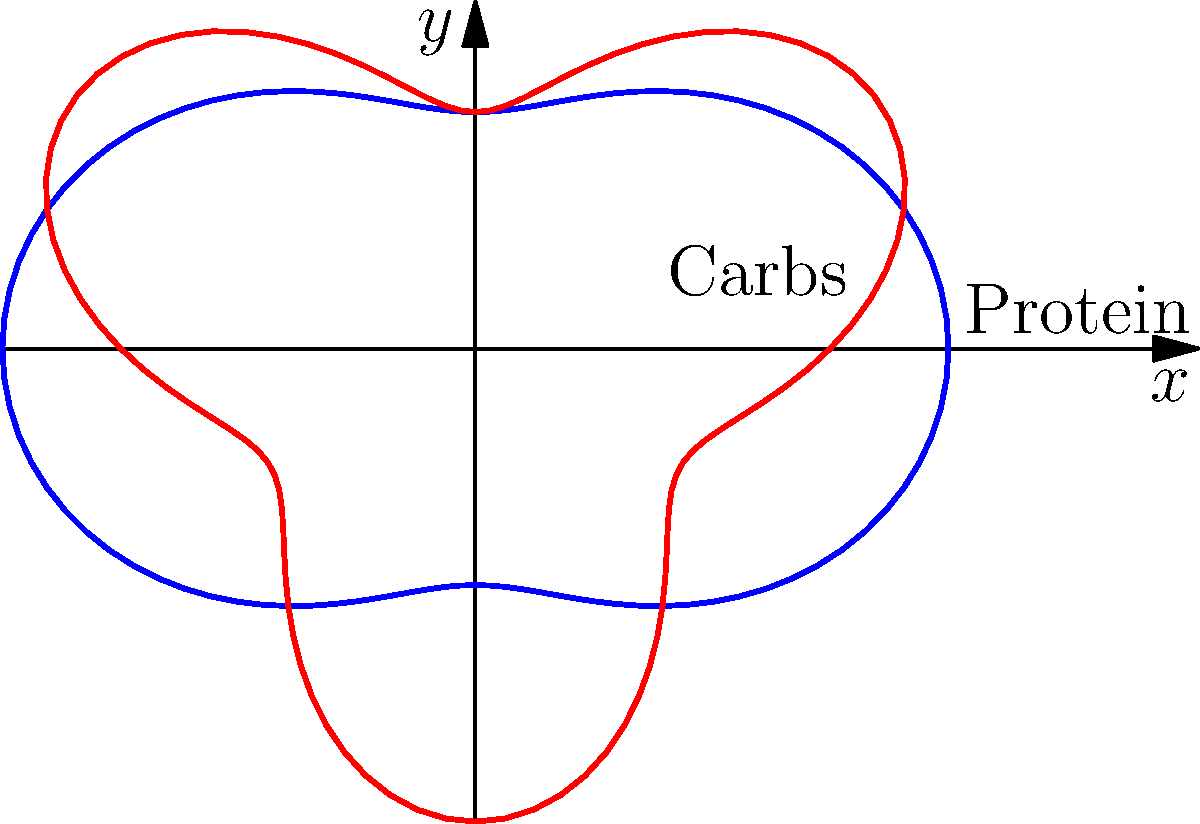The polar curves $r=3+\cos(2\theta)$ and $r=3+\sin(3\theta)$ represent the macronutrient ratios for protein and carbohydrates, respectively, during different gaming sessions. At which angle $\theta$ (in radians) do these curves intersect, indicating an optimal balance between protein and carbs for peak performance? To find the intersection point, we need to solve the equation:

$$3+\cos(2\theta) = 3+\sin(3\theta)$$

Simplifying:
$$\cos(2\theta) = \sin(3\theta)$$

Using the identity $\sin(3\theta) = 3\sin(\theta) - 4\sin^3(\theta)$, we get:
$$\cos(2\theta) = 3\sin(\theta) - 4\sin^3(\theta)$$

This equation is difficult to solve analytically, so we'll use a numerical method or graphical approach.

Plotting both sides of the equation, we can see they intersect at approximately $\theta = 0.5236$ radians.

To verify, we can substitute this value back into both original equations:

$$r_1 = 3 + \cos(2(0.5236)) \approx 3.5$$
$$r_2 = 3 + \sin(3(0.5236)) \approx 3.5$$

These values are approximately equal, confirming the intersection point.

Converting to degrees: $0.5236 \text{ radians} \approx 30°$

This suggests that the optimal balance between protein and carbohydrates occurs when $\theta$ is about 30° or $\pi/6$ radians.
Answer: $\pi/6$ radians 